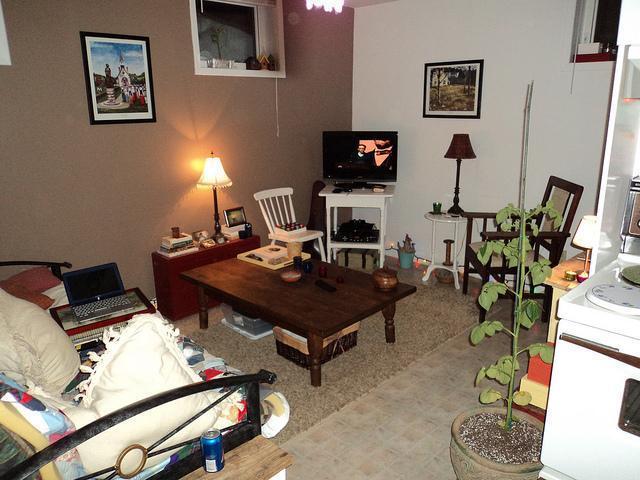How many lamps are on?
Give a very brief answer. 1. How many chairs can you see?
Give a very brief answer. 2. How many people is this meal for?
Give a very brief answer. 0. 